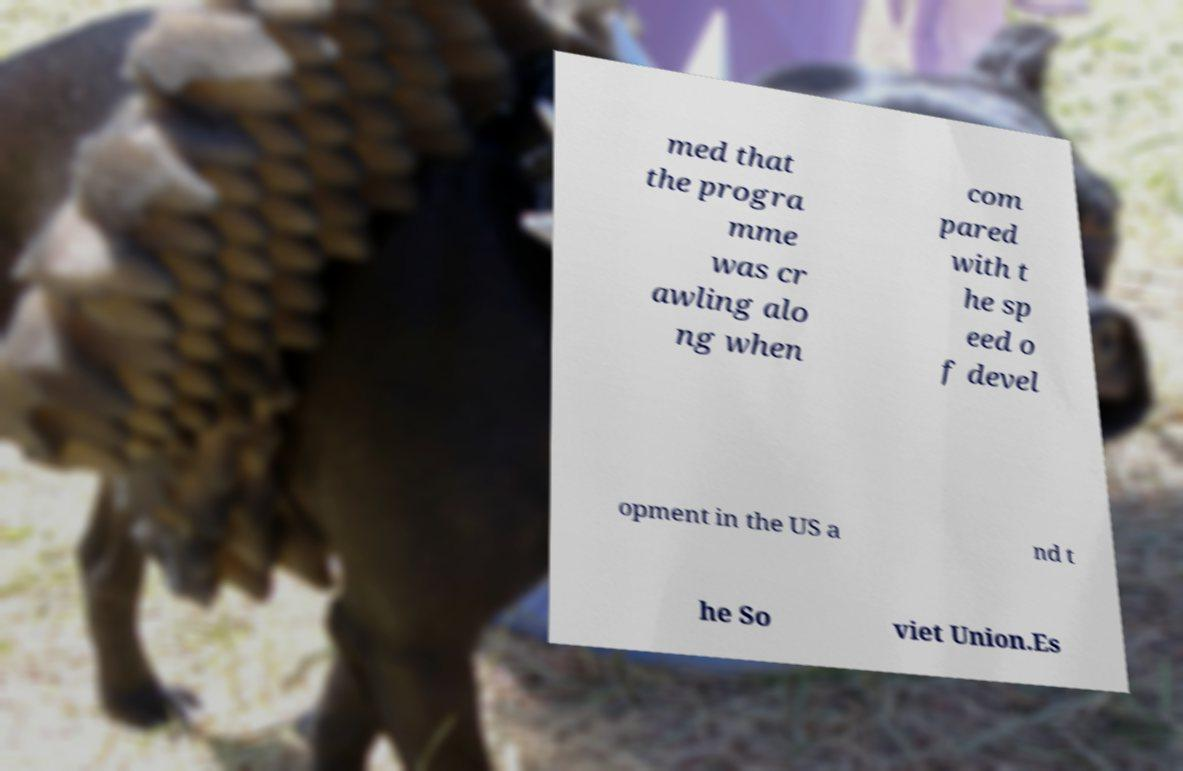What messages or text are displayed in this image? I need them in a readable, typed format. med that the progra mme was cr awling alo ng when com pared with t he sp eed o f devel opment in the US a nd t he So viet Union.Es 